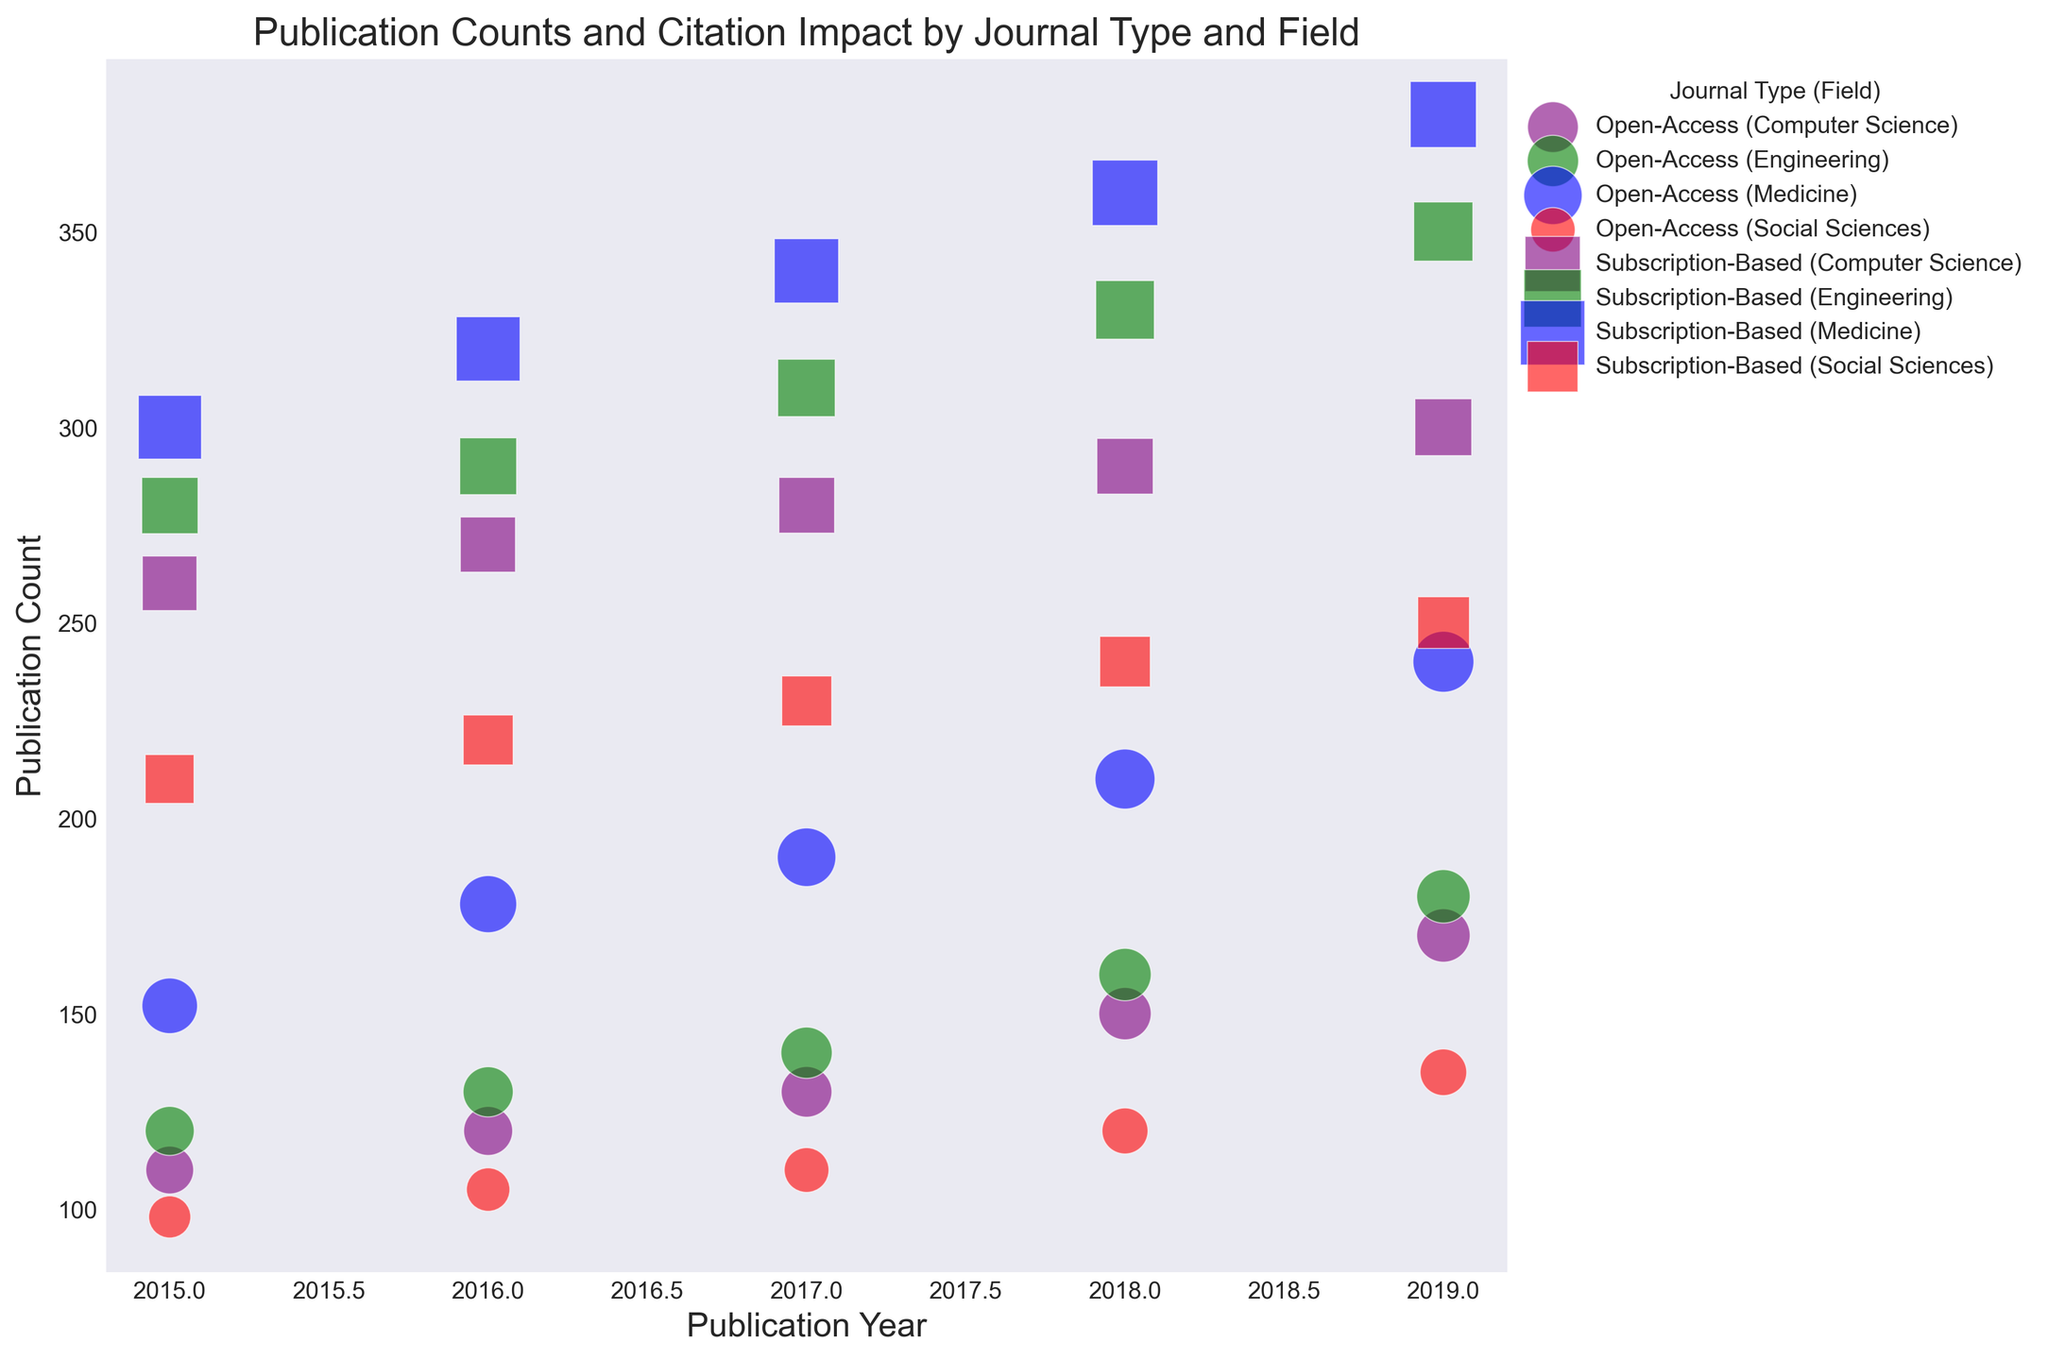What is the trend in publication counts for Open-Access journals in Medicine from 2015 to 2019? By examining the scatter plot, you can find the publication counts for Open-Access journals in Medicine from 2015 to 2019. The counts are represented by blue circles, and you can see a consistent upward trend from 152 in 2015, increasing each year to 240 in 2019.
Answer: Increasing Is the Citation Impact higher in Open-Access or Subscription-Based journals for Computer Science in 2019? By looking at the size of the markers which represent Citation Impact, in 2019, the purple square (Subscription-Based) is larger than the purple circle (Open-Access). The impact is 5.6 for Subscription-Based and 5.0 for Open-Access in Computer Science.
Answer: Subscription-Based Which field has the highest publication count for Subscription-Based journals in 2019? By examining the scatter plot, looking at the maximum point on the y-axis for 2019 among the square markers, Medicine has the highest publication count of 380 for Subscription-Based journals in 2019.
Answer: Medicine What is the average Citation Impact for Open-Access journals in Social Sciences across all years shown? To calculate the average Citation Impact for Open-Access in Social Sciences, sum the values 3.1, 3.3, 3.5, 3.7, and 3.8, which equals 17.4. Divide this by the number of years (5) to get the average of 17.4 / 5 = 3.48.
Answer: 3.48 How does the trend in Citation Impact for Open-Access journals in Engineering compare to Subscription-Based journals in the same field from 2015 to 2019? By observing the size of the markers for green circles (Open-Access) and green squares (Subscription-Based) from 2015 to 2019, both show an increasing trend. However, Subscription-Based journals have a higher Citation Impact throughout.
Answer: Both increasing, Subscription-Based higher Which field shows the least difference in publication count between Open-Access and Subscription-Based journals in 2019? By comparing the y-values (publication count) for each field in 2019, Social Sciences show the least difference with 135 for Open-Access and 250 for Subscription-Based, making a difference of 115, which is the smallest among all fields.
Answer: Social Sciences In which year did Open-Access journals in Medicine surpass 200 publications? By referencing the blue circles representing Medicine, the publication count surpasses 200 in 2018 with a value of 210.
Answer: 2018 What is the visual difference between markers for Open-Access and Subscription-Based journals? Open-Access journals are represented by circular markers, while Subscription-Based journals are represented by square markers.
Answer: Circular vs. square 